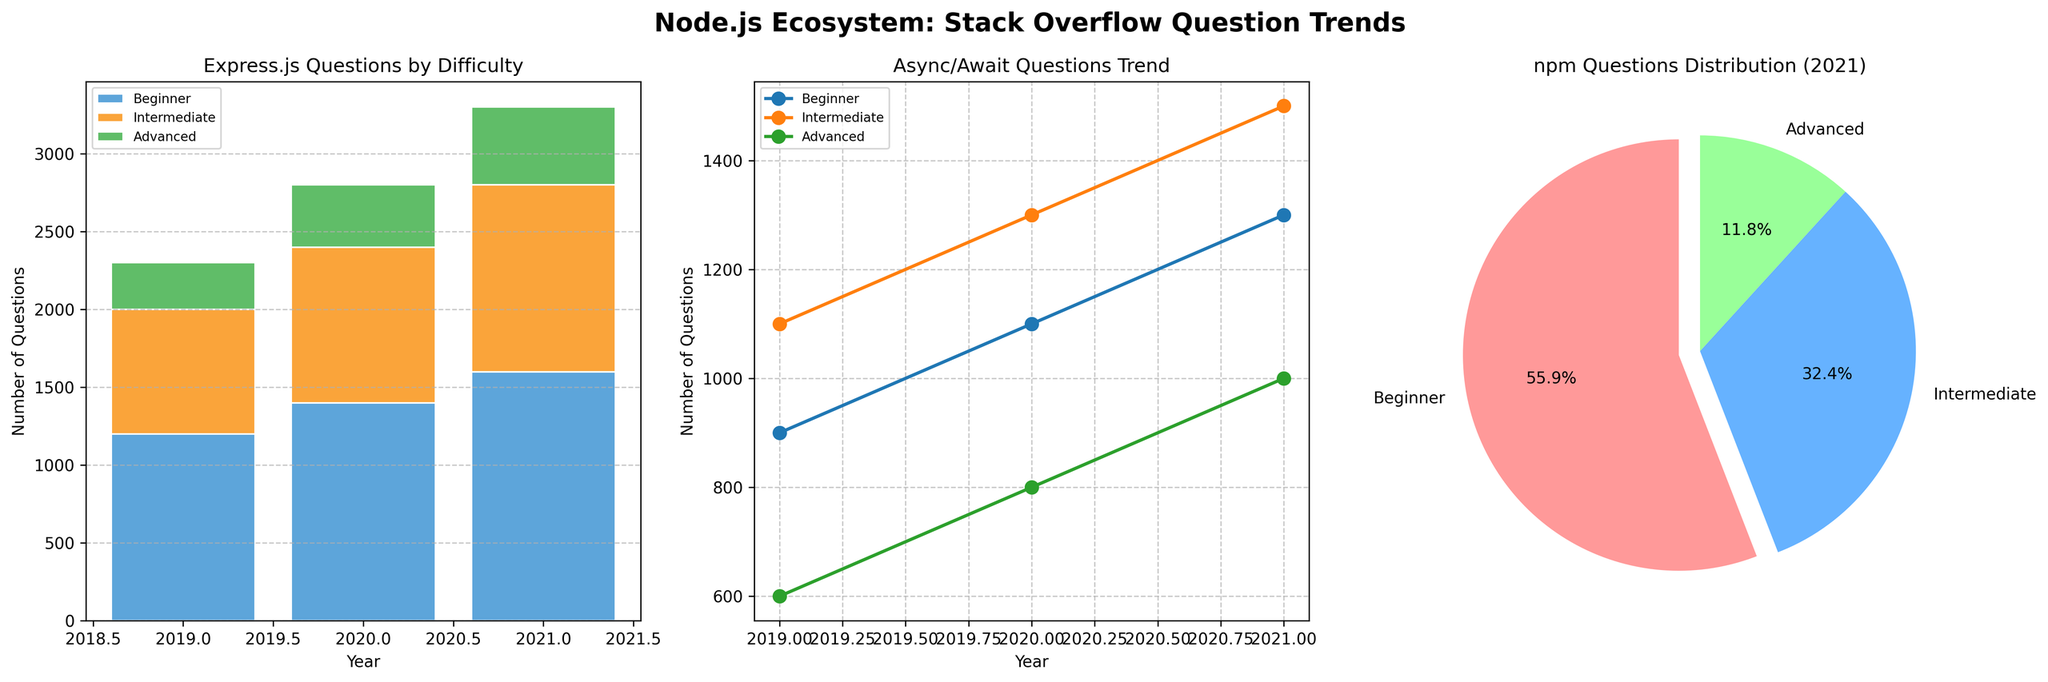What is the title of the entire figure? The title of the entire figure is written in bold at the top.
Answer: "Node.js Ecosystem: Stack Overflow Question Trends" Which year had the highest number of beginner questions for Express.js? Look at the stacked bar chart for Express.js. The tallest bar for 'Beginner' questions is in 2021.
Answer: 2021 How many more beginner questions were there for npm in 2021 compared to 2019? Compare the heights of the beginner bars for npm in the years 2019 and 2021 and subtract the 2019 value from the 2021 value.
Answer: 400 Did intermediate questions for Async/Await increase or decrease from 2019 to 2021? Look at the line plot for Async/Await. The line for 'Intermediate' rises from 2019 to 2021.
Answer: Increase What's the percentage of advanced npm questions in 2021? Refer to the pie chart for npm in 2021. The slice labeled 'Advanced' represents the percentage.
Answer: 13.3% Which difficulty level had the smallest number of questions for Express.js in 2020? In the stacked bar chart for Express.js in 2020, the smallest segment by height is 'Advanced'.
Answer: Advanced What is the average number of beginner questions for Async/Await between 2019 and 2021? Add up the beginner values for Async/Await for 2019, 2020, and 2021, and then divide by 3. (900+1100+1300)/3 = 1100
Answer: 1100 In the years shown, which difficulty level shows a continuous increase in questions for Express.js? Check the trends in the stacked bar chart for Express.js. Only 'Beginner' continuously increases from 2019 to 2021.
Answer: Beginner Which topic had the highest number of questions at any single difficulty level in 2021? Compare the highest points in the 2021 bars/lines/pie slices. npm Beginner had 1900 questions, the highest.
Answer: npm Beginner 